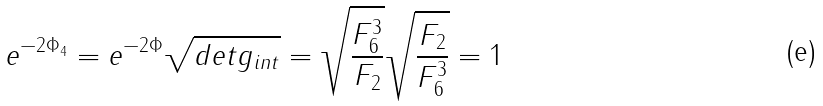Convert formula to latex. <formula><loc_0><loc_0><loc_500><loc_500>e ^ { - 2 \Phi _ { 4 } } = e ^ { - 2 \Phi } \sqrt { d e t g _ { i n t } } = \sqrt { \frac { F _ { 6 } ^ { 3 } } { F _ { 2 } } } \sqrt { \frac { F _ { 2 } } { F _ { 6 } ^ { 3 } } } = 1</formula> 